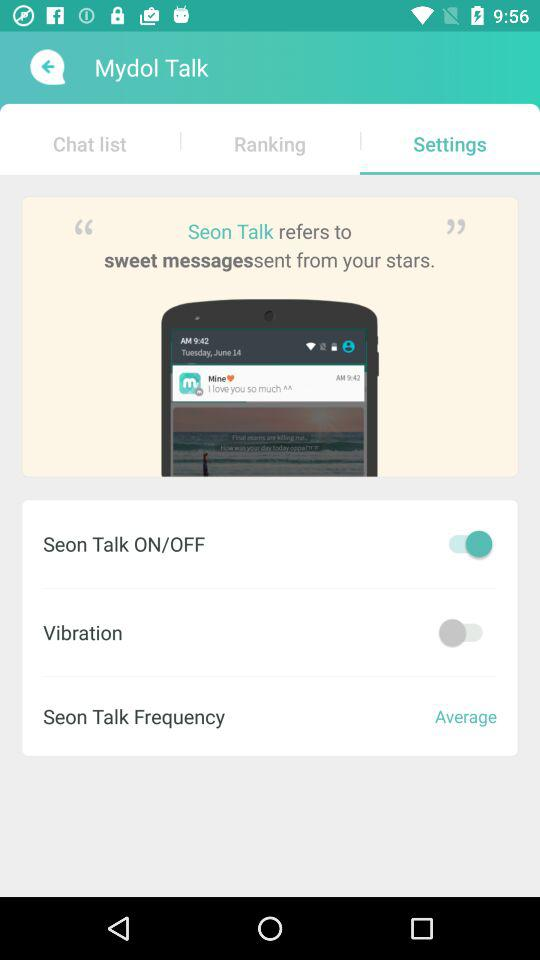What setting is enabled? The setting is "Seon Talk ON/OFF". 